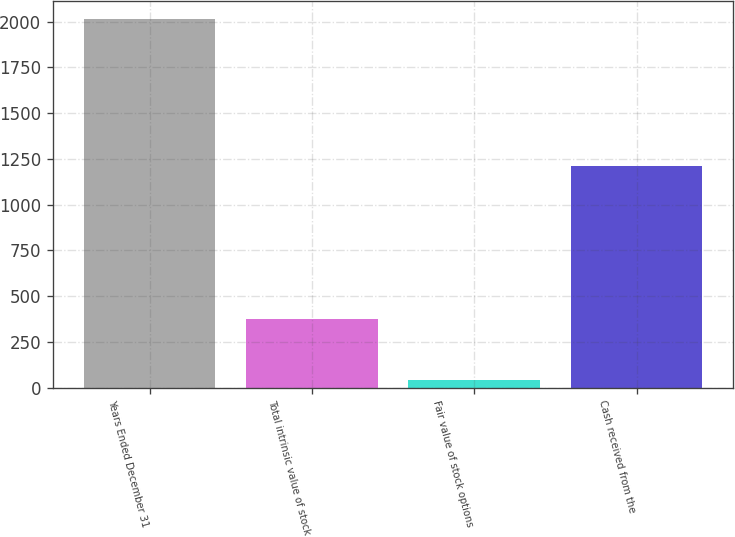Convert chart to OTSL. <chart><loc_0><loc_0><loc_500><loc_500><bar_chart><fcel>Years Ended December 31<fcel>Total intrinsic value of stock<fcel>Fair value of stock options<fcel>Cash received from the<nl><fcel>2013<fcel>374<fcel>42<fcel>1210<nl></chart> 